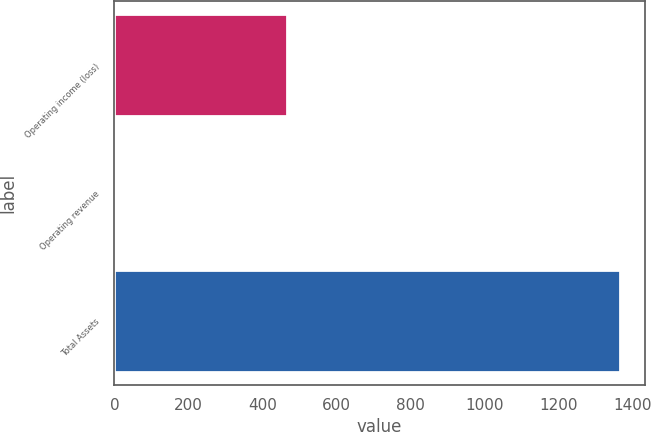<chart> <loc_0><loc_0><loc_500><loc_500><bar_chart><fcel>Operating income (loss)<fcel>Operating revenue<fcel>Total Assets<nl><fcel>468<fcel>2<fcel>1366<nl></chart> 